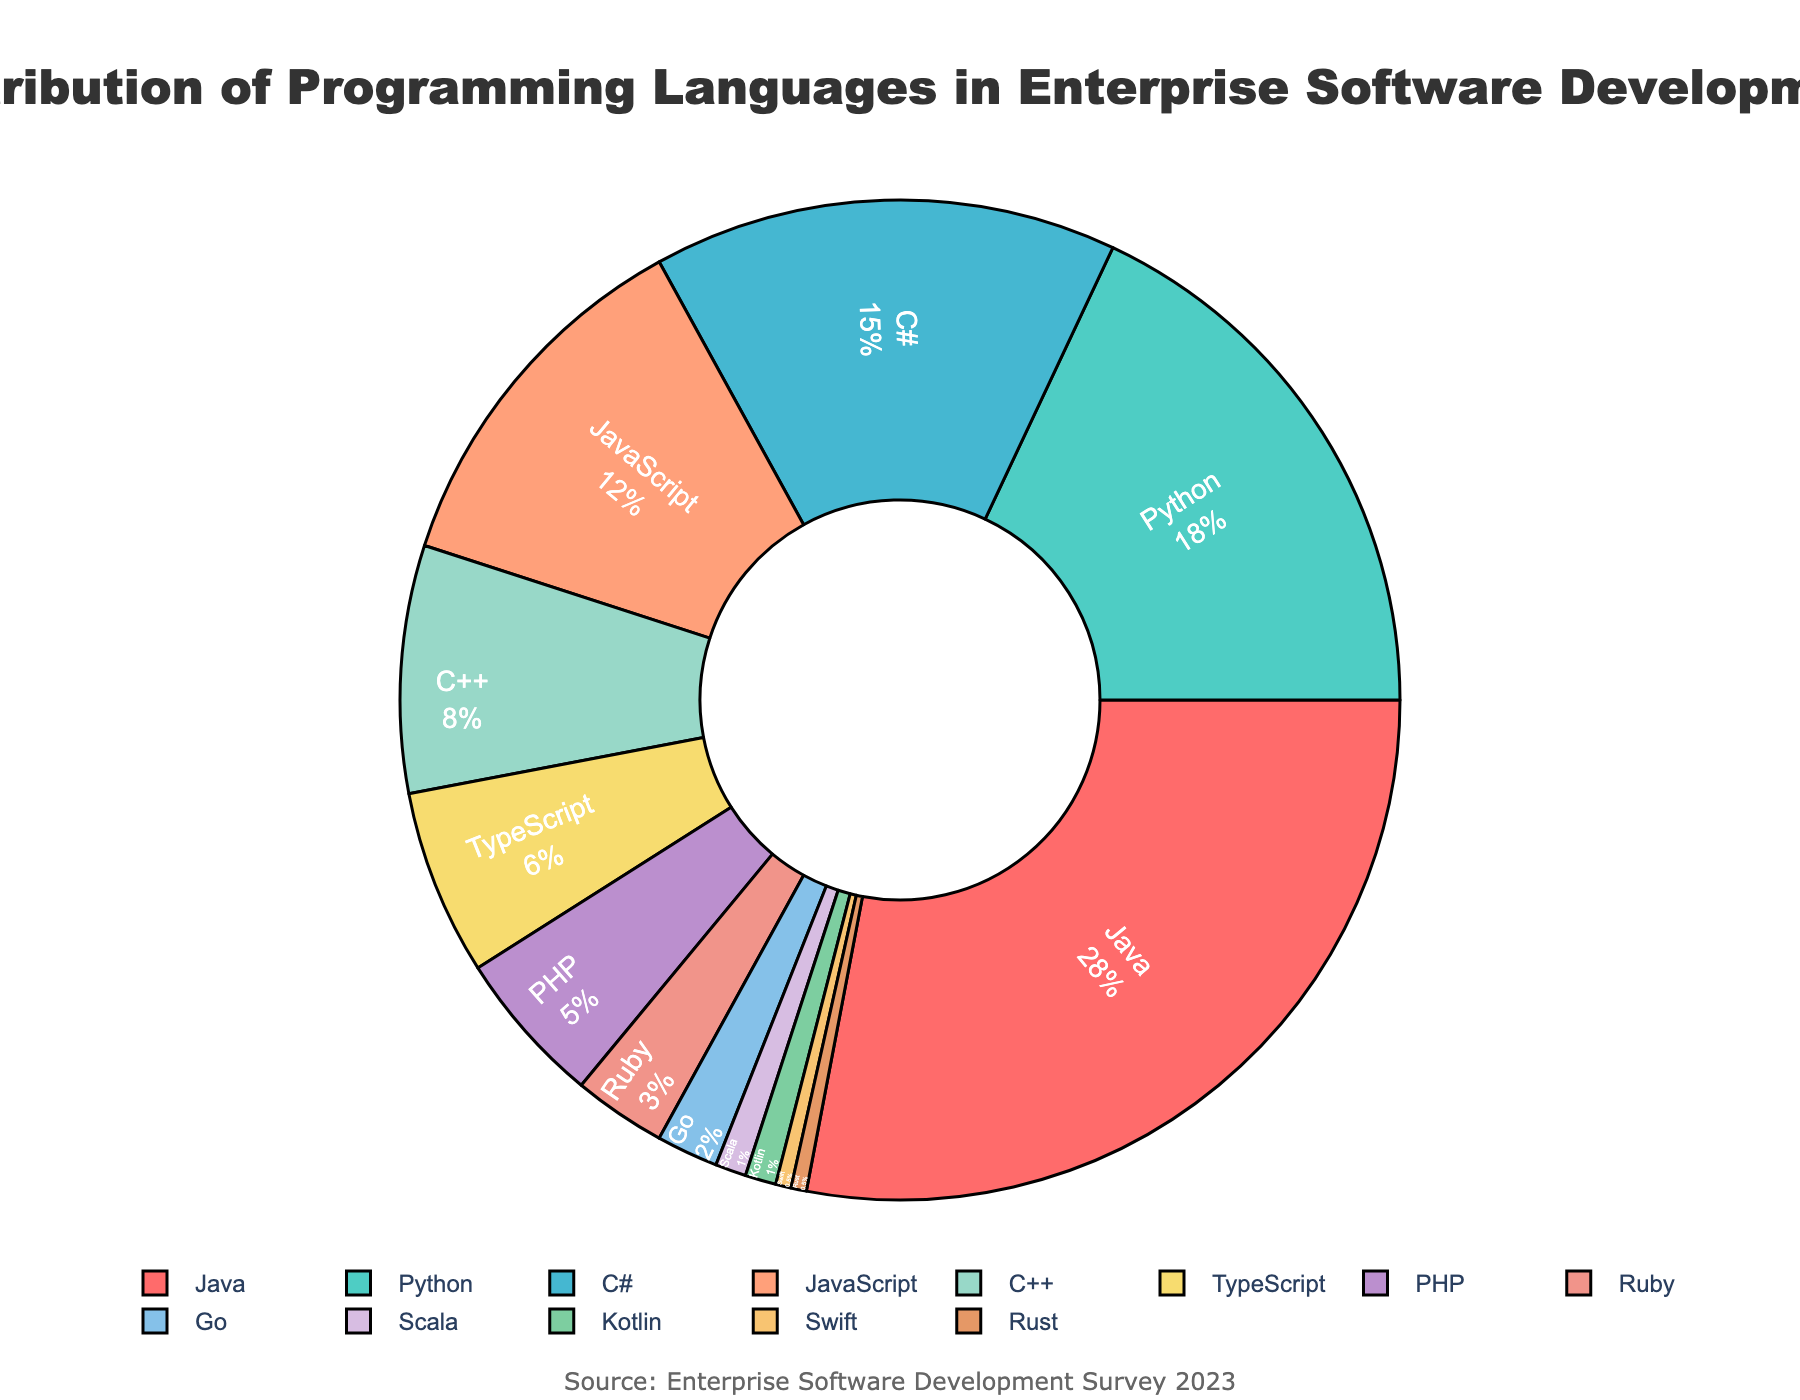What's the most commonly used programming language in enterprise software development? The largest segment in the pie chart represents the most used language. Java has the largest percentage at 28%.
Answer: Java Which language is used more, Python or C#? Compare the segments representing Python and C#. Python has 18%, while C# has 15%. Thus, Python is used more than C#.
Answer: Python What is the combined percentage for JavaScript, TypeScript, and PHP? Add the percentages for JavaScript (12%), TypeScript (6%), and PHP (5%). 12% + 6% + 5% = 23%.
Answer: 23% How many languages have a usage percentage of 5% or less? Identify the segments that represent languages with 5% or less. PHP (5%), Ruby (3%), Go (2%), Scala (1%), Kotlin (1%), Swift (0.5%), and Rust (0.5%) fit this criteria, making a total of 7 languages.
Answer: 7 Which language has the smallest percentage, and what is it? The smallest segment represents the least used language. Both Swift and Rust have the smallest percentage at 0.5%.
Answer: Swift and Rust Is the combined percentage of Go, Scala, Kotlin, and Rust greater than that of C++? Add the percentages for Go (2%), Scala (1%), Kotlin (1%), and Rust (0.5% + 0.5%), resulting in 4%. Compare 4% with C++ which has 8%. 4% is less than 8%.
Answer: No What percentage of the total usage do the top three languages represent? Add the percentages for Java (28%), Python (18%), and C# (15%). 28% + 18% + 15% = 61%.
Answer: 61% Which language segment is represented by the color green? Visually identify the segment colored green. Python is represented by the color green.
Answer: Python Is Java used more than twice the combined percentage of Go, Scala, Kotlin, and Rust? Combine the percentages for Go (2%), Scala (1%), Kotlin (1%), and Rust (0.5% + 0.5%), totaling 4%. Compare it to Java's 28%. Java's 28% is more than twice the combined 4%.
Answer: Yes What is the combined percentage of all languages used less than TypeScript? Identify the languages used less than TypeScript (6%): PHP (5%), Ruby (3%), Go (2%), Scala (1%), Kotlin (1%), Swift (0.5%), and Rust (0.5%) and sum their percentages 5% + 3% + 2% + 1% + 1% + 0.5% + 0.5% = 13%.
Answer: 13% 